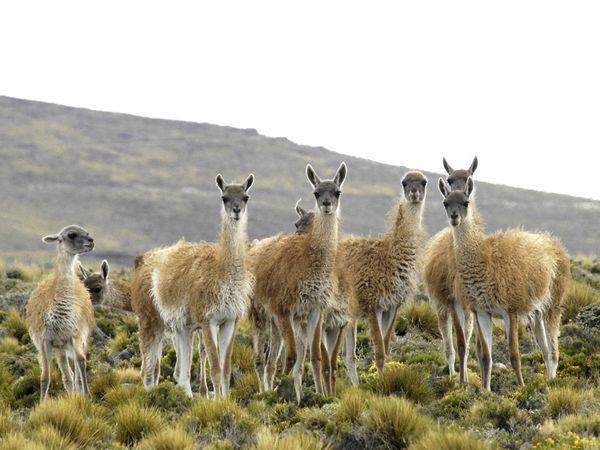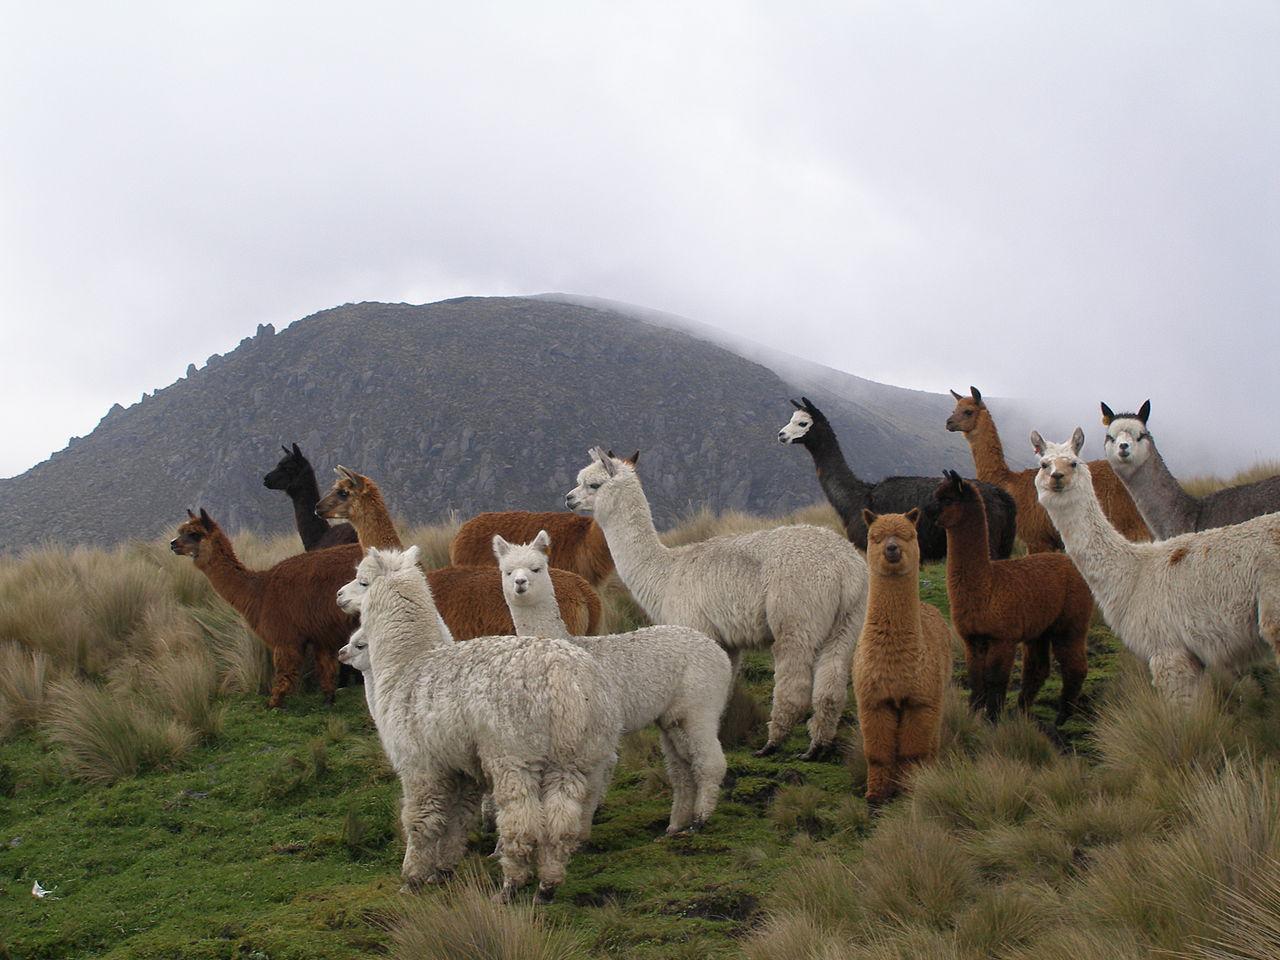The first image is the image on the left, the second image is the image on the right. Assess this claim about the two images: "The left image shows a small group of different colored llamas who aren't wearing anything, and the right image inludes at least one rightward-facing llama who is grazing.". Correct or not? Answer yes or no. No. The first image is the image on the left, the second image is the image on the right. Analyze the images presented: Is the assertion "There are at least three llamas walking forward over big rocks." valid? Answer yes or no. No. 